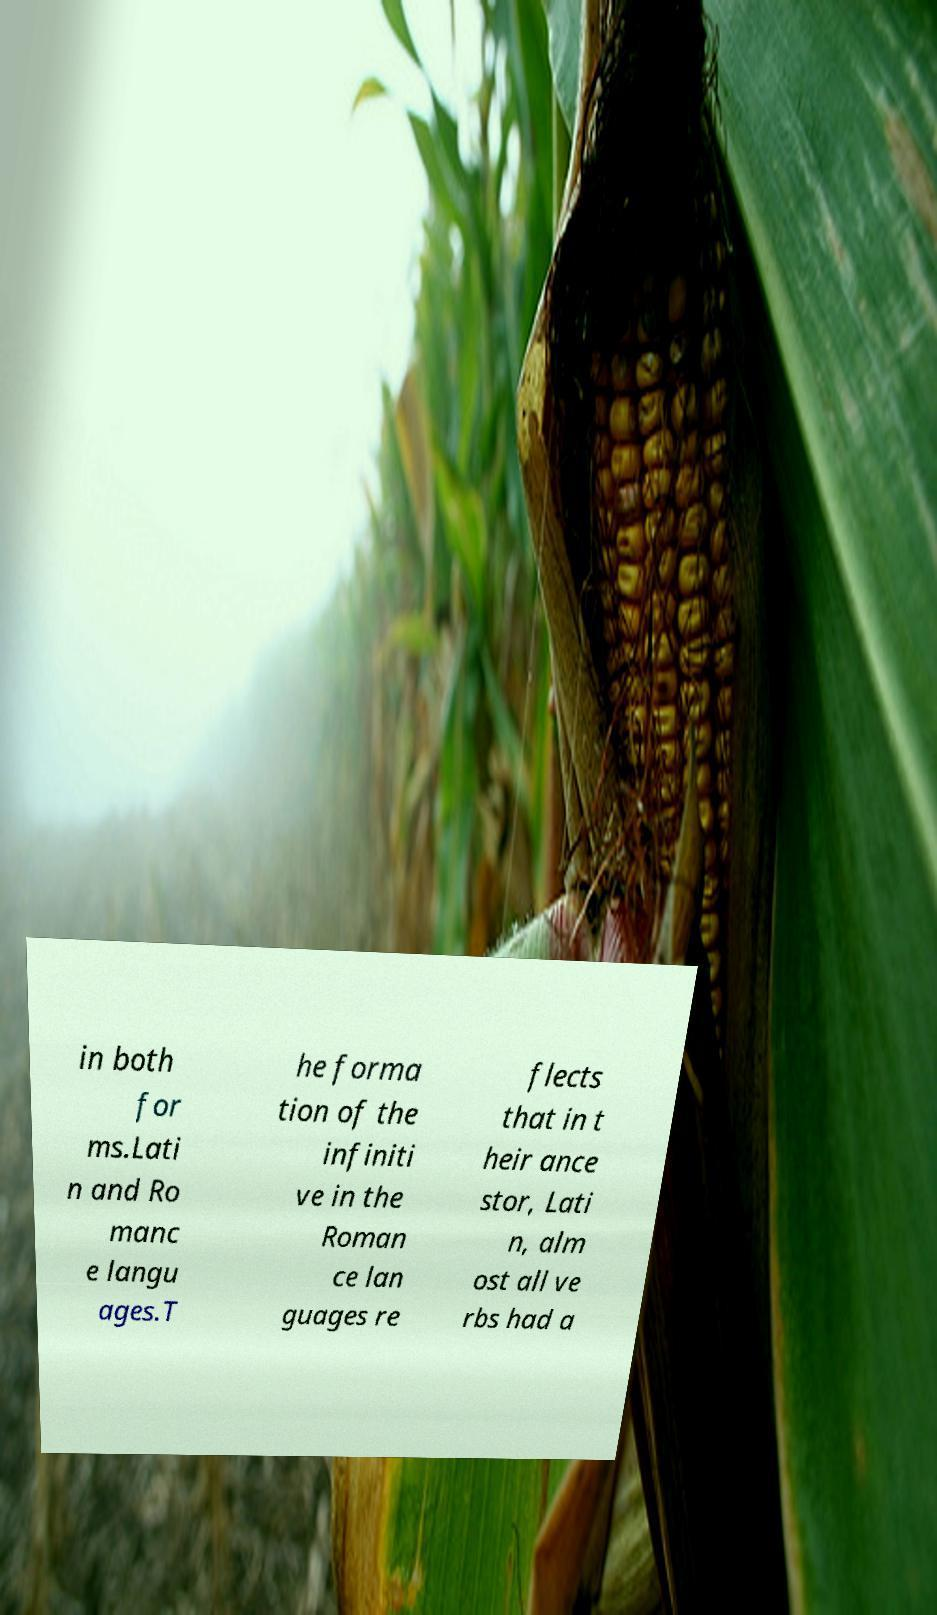Please read and relay the text visible in this image. What does it say? in both for ms.Lati n and Ro manc e langu ages.T he forma tion of the infiniti ve in the Roman ce lan guages re flects that in t heir ance stor, Lati n, alm ost all ve rbs had a 